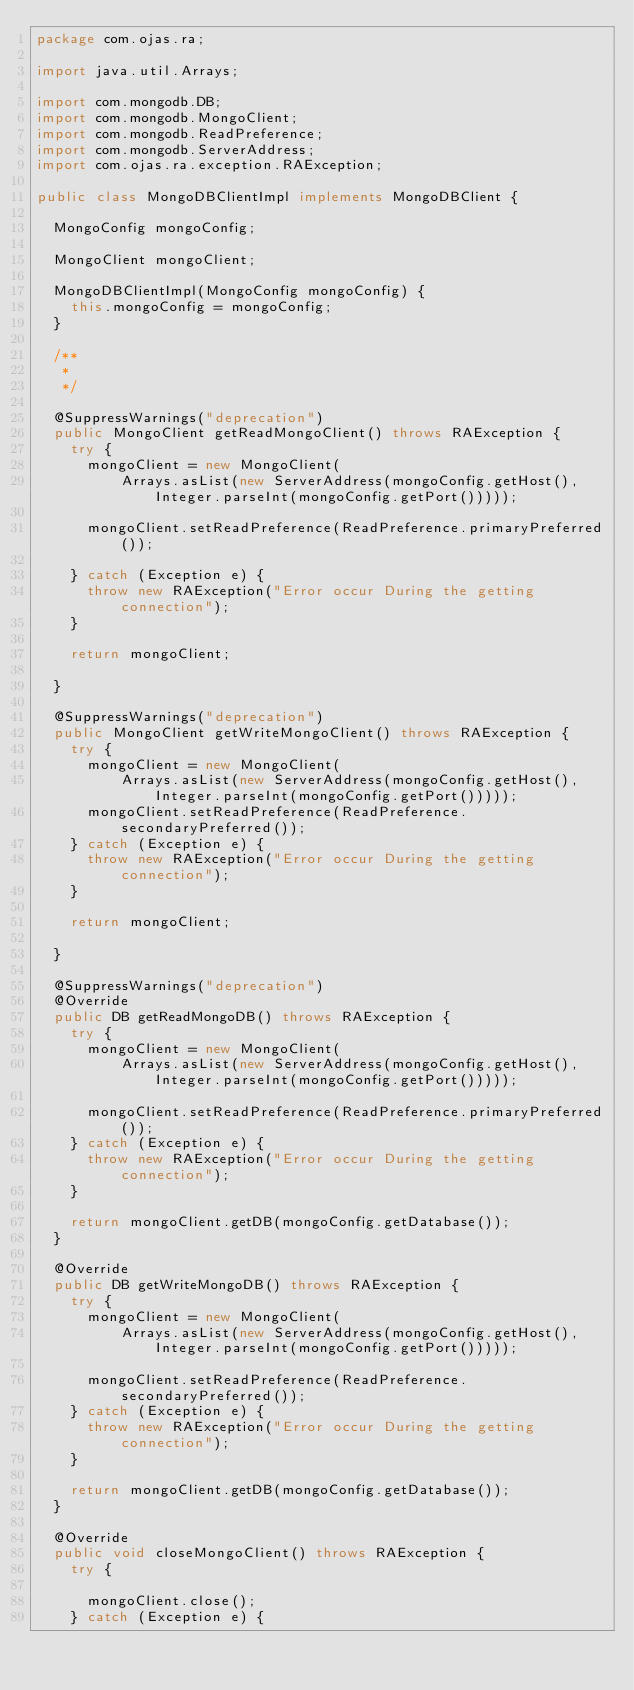<code> <loc_0><loc_0><loc_500><loc_500><_Java_>package com.ojas.ra;

import java.util.Arrays;

import com.mongodb.DB;
import com.mongodb.MongoClient;
import com.mongodb.ReadPreference;
import com.mongodb.ServerAddress;
import com.ojas.ra.exception.RAException;

public class MongoDBClientImpl implements MongoDBClient {

	MongoConfig mongoConfig;

	MongoClient mongoClient;

	MongoDBClientImpl(MongoConfig mongoConfig) {
		this.mongoConfig = mongoConfig;
	}

	/**
	 * 
	 */

	@SuppressWarnings("deprecation")
	public MongoClient getReadMongoClient() throws RAException {
		try {
			mongoClient = new MongoClient(
					Arrays.asList(new ServerAddress(mongoConfig.getHost(), Integer.parseInt(mongoConfig.getPort()))));

			mongoClient.setReadPreference(ReadPreference.primaryPreferred());

		} catch (Exception e) {
			throw new RAException("Error occur During the getting connection");
		}

		return mongoClient;

	}

	@SuppressWarnings("deprecation")
	public MongoClient getWriteMongoClient() throws RAException {
		try {
			mongoClient = new MongoClient(
					Arrays.asList(new ServerAddress(mongoConfig.getHost(), Integer.parseInt(mongoConfig.getPort()))));
			mongoClient.setReadPreference(ReadPreference.secondaryPreferred());
		} catch (Exception e) {
			throw new RAException("Error occur During the getting connection");
		}

		return mongoClient;

	}

	@SuppressWarnings("deprecation")
	@Override
	public DB getReadMongoDB() throws RAException {
		try {
			mongoClient = new MongoClient(
					Arrays.asList(new ServerAddress(mongoConfig.getHost(), Integer.parseInt(mongoConfig.getPort()))));

			mongoClient.setReadPreference(ReadPreference.primaryPreferred());
		} catch (Exception e) {
			throw new RAException("Error occur During the getting connection");
		}

		return mongoClient.getDB(mongoConfig.getDatabase());
	}

	@Override
	public DB getWriteMongoDB() throws RAException {
		try {
			mongoClient = new MongoClient(
					Arrays.asList(new ServerAddress(mongoConfig.getHost(), Integer.parseInt(mongoConfig.getPort()))));

			mongoClient.setReadPreference(ReadPreference.secondaryPreferred());
		} catch (Exception e) {
			throw new RAException("Error occur During the getting connection");
		}

		return mongoClient.getDB(mongoConfig.getDatabase());
	}

	@Override
	public void closeMongoClient() throws RAException {
		try {

			mongoClient.close();
		} catch (Exception e) {</code> 